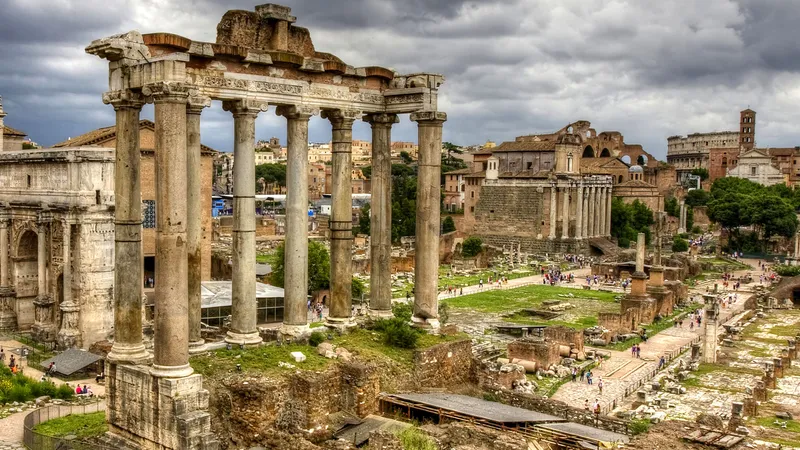What might have been the daily activities in this area during ancient times? In ancient times, the Roman Forum was a dynamic and bustling marketplace, public square, and judicial and political center. Daily activities would have included trading of goods, both local and exotic, in the markets; legal disputes being argued and resolved in the basilicas; political campaigns and elections taking place among the temples and rostra; and citizens discussing civic matters. It would have been filled with a cacophony of sounds from vendors, politicians, citizens, and visitors - a true center of Roman daily life. 